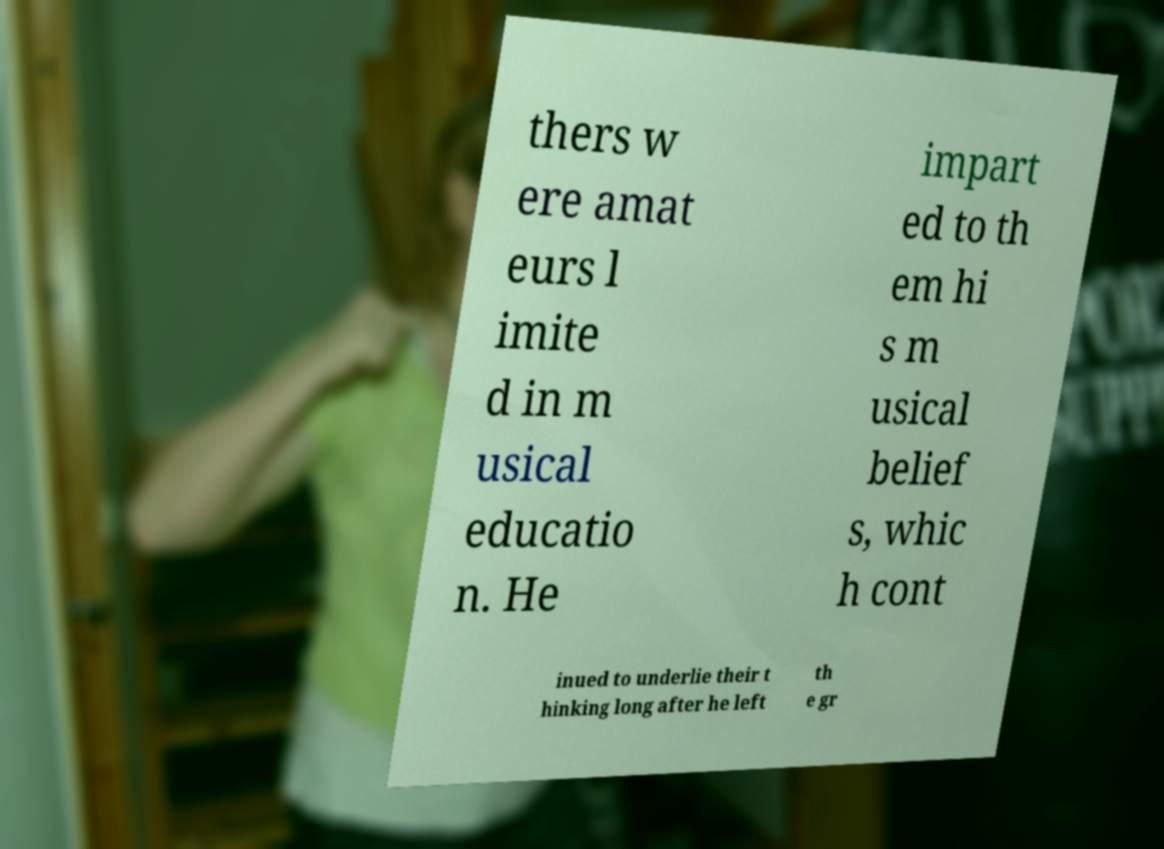Please identify and transcribe the text found in this image. thers w ere amat eurs l imite d in m usical educatio n. He impart ed to th em hi s m usical belief s, whic h cont inued to underlie their t hinking long after he left th e gr 